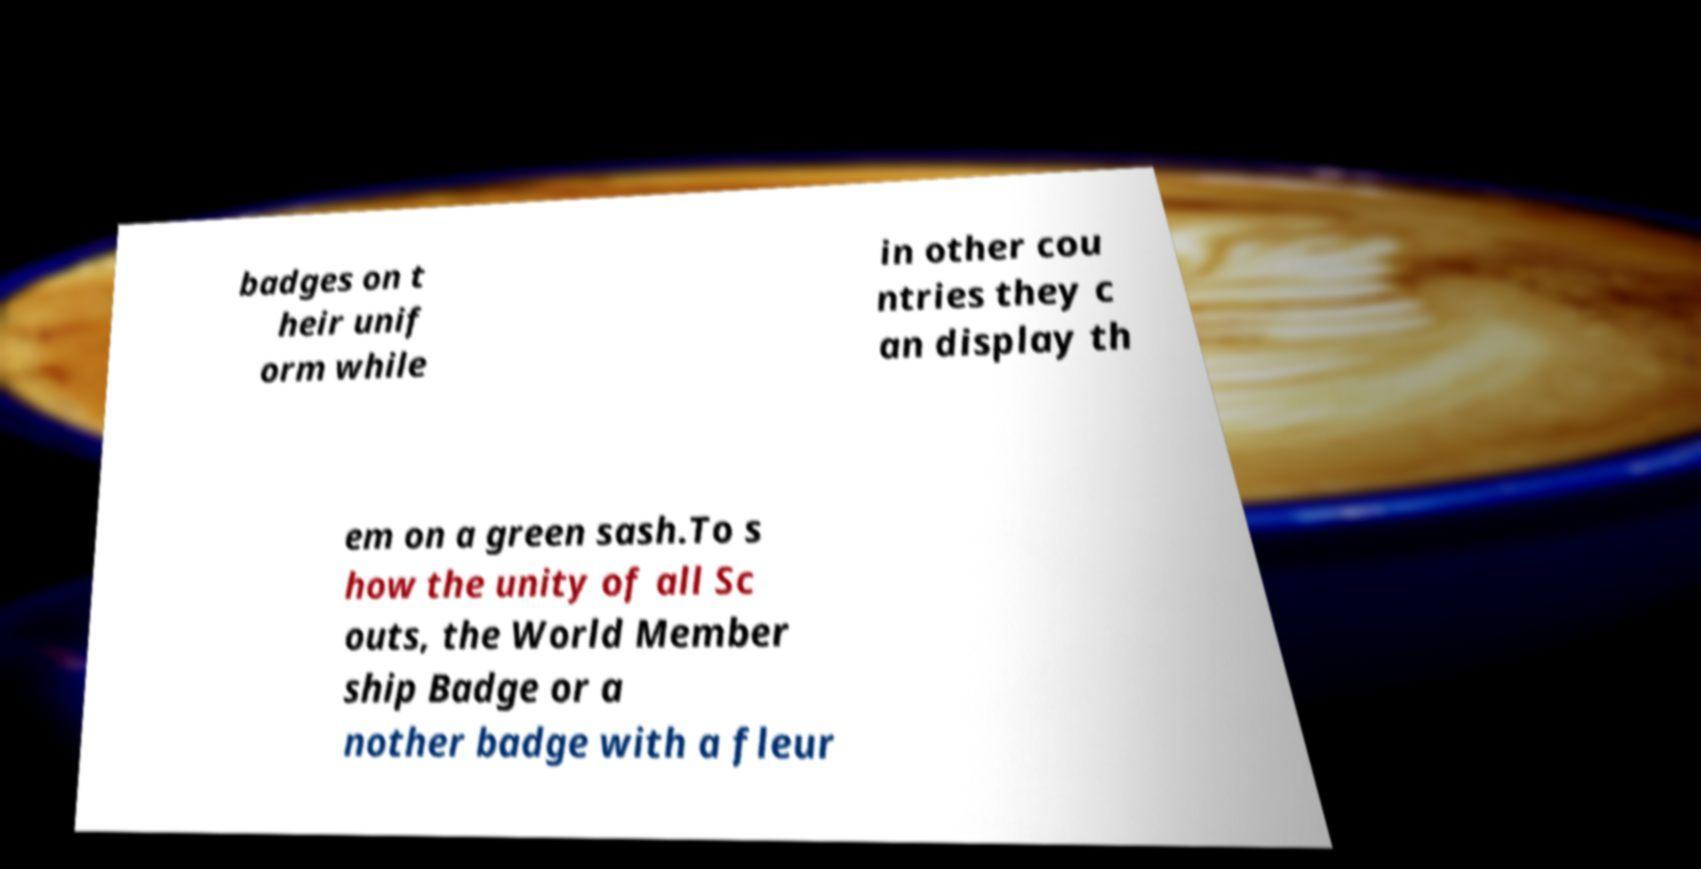I need the written content from this picture converted into text. Can you do that? badges on t heir unif orm while in other cou ntries they c an display th em on a green sash.To s how the unity of all Sc outs, the World Member ship Badge or a nother badge with a fleur 